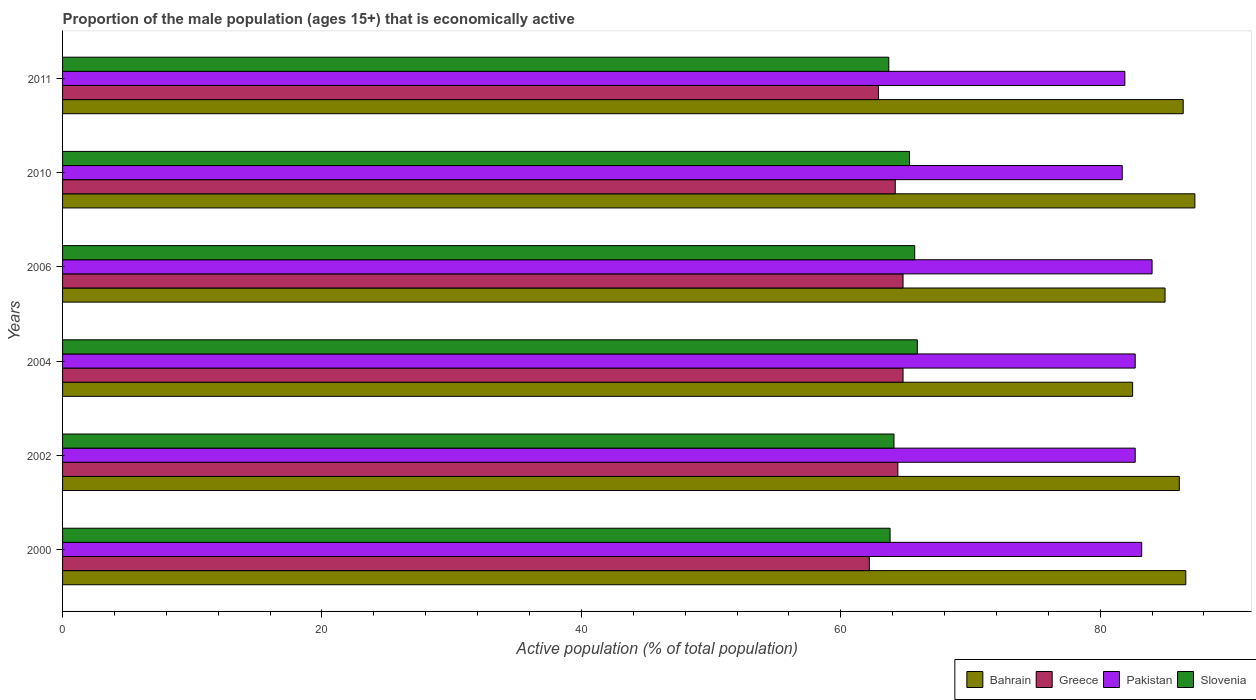How many different coloured bars are there?
Provide a succinct answer. 4. Are the number of bars per tick equal to the number of legend labels?
Provide a succinct answer. Yes. Are the number of bars on each tick of the Y-axis equal?
Offer a very short reply. Yes. How many bars are there on the 3rd tick from the top?
Provide a short and direct response. 4. What is the proportion of the male population that is economically active in Slovenia in 2000?
Ensure brevity in your answer.  63.8. Across all years, what is the maximum proportion of the male population that is economically active in Bahrain?
Keep it short and to the point. 87.3. Across all years, what is the minimum proportion of the male population that is economically active in Greece?
Your answer should be very brief. 62.2. In which year was the proportion of the male population that is economically active in Pakistan maximum?
Ensure brevity in your answer.  2006. What is the total proportion of the male population that is economically active in Slovenia in the graph?
Your response must be concise. 388.5. What is the difference between the proportion of the male population that is economically active in Slovenia in 2000 and that in 2006?
Your answer should be very brief. -1.9. What is the difference between the proportion of the male population that is economically active in Slovenia in 2010 and the proportion of the male population that is economically active in Greece in 2011?
Provide a succinct answer. 2.4. What is the average proportion of the male population that is economically active in Pakistan per year?
Provide a succinct answer. 82.7. In the year 2002, what is the difference between the proportion of the male population that is economically active in Pakistan and proportion of the male population that is economically active in Bahrain?
Offer a terse response. -3.4. In how many years, is the proportion of the male population that is economically active in Greece greater than 56 %?
Give a very brief answer. 6. What is the ratio of the proportion of the male population that is economically active in Slovenia in 2000 to that in 2002?
Your response must be concise. 1. Is the difference between the proportion of the male population that is economically active in Pakistan in 2000 and 2004 greater than the difference between the proportion of the male population that is economically active in Bahrain in 2000 and 2004?
Ensure brevity in your answer.  No. What is the difference between the highest and the lowest proportion of the male population that is economically active in Bahrain?
Your answer should be compact. 4.8. Is it the case that in every year, the sum of the proportion of the male population that is economically active in Greece and proportion of the male population that is economically active in Bahrain is greater than the sum of proportion of the male population that is economically active in Slovenia and proportion of the male population that is economically active in Pakistan?
Offer a very short reply. No. What does the 1st bar from the top in 2011 represents?
Give a very brief answer. Slovenia. What is the difference between two consecutive major ticks on the X-axis?
Offer a terse response. 20. How many legend labels are there?
Offer a very short reply. 4. How are the legend labels stacked?
Offer a very short reply. Horizontal. What is the title of the graph?
Your answer should be compact. Proportion of the male population (ages 15+) that is economically active. Does "Kenya" appear as one of the legend labels in the graph?
Offer a very short reply. No. What is the label or title of the X-axis?
Offer a terse response. Active population (% of total population). What is the Active population (% of total population) of Bahrain in 2000?
Offer a very short reply. 86.6. What is the Active population (% of total population) of Greece in 2000?
Offer a very short reply. 62.2. What is the Active population (% of total population) in Pakistan in 2000?
Provide a succinct answer. 83.2. What is the Active population (% of total population) of Slovenia in 2000?
Provide a succinct answer. 63.8. What is the Active population (% of total population) of Bahrain in 2002?
Make the answer very short. 86.1. What is the Active population (% of total population) of Greece in 2002?
Give a very brief answer. 64.4. What is the Active population (% of total population) of Pakistan in 2002?
Offer a terse response. 82.7. What is the Active population (% of total population) in Slovenia in 2002?
Your answer should be compact. 64.1. What is the Active population (% of total population) in Bahrain in 2004?
Your answer should be very brief. 82.5. What is the Active population (% of total population) in Greece in 2004?
Keep it short and to the point. 64.8. What is the Active population (% of total population) in Pakistan in 2004?
Keep it short and to the point. 82.7. What is the Active population (% of total population) of Slovenia in 2004?
Make the answer very short. 65.9. What is the Active population (% of total population) of Bahrain in 2006?
Your response must be concise. 85. What is the Active population (% of total population) of Greece in 2006?
Give a very brief answer. 64.8. What is the Active population (% of total population) in Slovenia in 2006?
Your response must be concise. 65.7. What is the Active population (% of total population) in Bahrain in 2010?
Your response must be concise. 87.3. What is the Active population (% of total population) of Greece in 2010?
Keep it short and to the point. 64.2. What is the Active population (% of total population) in Pakistan in 2010?
Your answer should be compact. 81.7. What is the Active population (% of total population) in Slovenia in 2010?
Offer a terse response. 65.3. What is the Active population (% of total population) of Bahrain in 2011?
Ensure brevity in your answer.  86.4. What is the Active population (% of total population) of Greece in 2011?
Offer a terse response. 62.9. What is the Active population (% of total population) of Pakistan in 2011?
Your answer should be compact. 81.9. What is the Active population (% of total population) of Slovenia in 2011?
Your response must be concise. 63.7. Across all years, what is the maximum Active population (% of total population) of Bahrain?
Your response must be concise. 87.3. Across all years, what is the maximum Active population (% of total population) in Greece?
Provide a short and direct response. 64.8. Across all years, what is the maximum Active population (% of total population) in Slovenia?
Make the answer very short. 65.9. Across all years, what is the minimum Active population (% of total population) in Bahrain?
Offer a terse response. 82.5. Across all years, what is the minimum Active population (% of total population) of Greece?
Make the answer very short. 62.2. Across all years, what is the minimum Active population (% of total population) of Pakistan?
Make the answer very short. 81.7. Across all years, what is the minimum Active population (% of total population) of Slovenia?
Offer a terse response. 63.7. What is the total Active population (% of total population) of Bahrain in the graph?
Ensure brevity in your answer.  513.9. What is the total Active population (% of total population) of Greece in the graph?
Ensure brevity in your answer.  383.3. What is the total Active population (% of total population) in Pakistan in the graph?
Your answer should be compact. 496.2. What is the total Active population (% of total population) in Slovenia in the graph?
Provide a succinct answer. 388.5. What is the difference between the Active population (% of total population) of Pakistan in 2000 and that in 2004?
Provide a short and direct response. 0.5. What is the difference between the Active population (% of total population) of Slovenia in 2000 and that in 2004?
Your answer should be compact. -2.1. What is the difference between the Active population (% of total population) of Greece in 2000 and that in 2006?
Give a very brief answer. -2.6. What is the difference between the Active population (% of total population) in Pakistan in 2000 and that in 2006?
Keep it short and to the point. -0.8. What is the difference between the Active population (% of total population) in Slovenia in 2000 and that in 2006?
Your response must be concise. -1.9. What is the difference between the Active population (% of total population) of Greece in 2000 and that in 2010?
Make the answer very short. -2. What is the difference between the Active population (% of total population) in Slovenia in 2000 and that in 2010?
Ensure brevity in your answer.  -1.5. What is the difference between the Active population (% of total population) in Bahrain in 2000 and that in 2011?
Keep it short and to the point. 0.2. What is the difference between the Active population (% of total population) of Greece in 2000 and that in 2011?
Your answer should be very brief. -0.7. What is the difference between the Active population (% of total population) in Slovenia in 2000 and that in 2011?
Give a very brief answer. 0.1. What is the difference between the Active population (% of total population) of Bahrain in 2002 and that in 2004?
Provide a short and direct response. 3.6. What is the difference between the Active population (% of total population) of Slovenia in 2002 and that in 2004?
Your answer should be very brief. -1.8. What is the difference between the Active population (% of total population) of Bahrain in 2002 and that in 2006?
Ensure brevity in your answer.  1.1. What is the difference between the Active population (% of total population) in Greece in 2002 and that in 2006?
Keep it short and to the point. -0.4. What is the difference between the Active population (% of total population) of Pakistan in 2002 and that in 2006?
Keep it short and to the point. -1.3. What is the difference between the Active population (% of total population) in Slovenia in 2002 and that in 2006?
Ensure brevity in your answer.  -1.6. What is the difference between the Active population (% of total population) in Bahrain in 2002 and that in 2010?
Your response must be concise. -1.2. What is the difference between the Active population (% of total population) in Slovenia in 2002 and that in 2011?
Offer a terse response. 0.4. What is the difference between the Active population (% of total population) in Bahrain in 2004 and that in 2006?
Keep it short and to the point. -2.5. What is the difference between the Active population (% of total population) in Greece in 2004 and that in 2010?
Offer a terse response. 0.6. What is the difference between the Active population (% of total population) of Pakistan in 2004 and that in 2010?
Make the answer very short. 1. What is the difference between the Active population (% of total population) of Slovenia in 2004 and that in 2010?
Provide a short and direct response. 0.6. What is the difference between the Active population (% of total population) of Pakistan in 2004 and that in 2011?
Offer a very short reply. 0.8. What is the difference between the Active population (% of total population) of Bahrain in 2006 and that in 2010?
Ensure brevity in your answer.  -2.3. What is the difference between the Active population (% of total population) in Slovenia in 2006 and that in 2010?
Provide a succinct answer. 0.4. What is the difference between the Active population (% of total population) in Greece in 2006 and that in 2011?
Offer a very short reply. 1.9. What is the difference between the Active population (% of total population) of Bahrain in 2010 and that in 2011?
Provide a short and direct response. 0.9. What is the difference between the Active population (% of total population) in Slovenia in 2010 and that in 2011?
Offer a terse response. 1.6. What is the difference between the Active population (% of total population) in Bahrain in 2000 and the Active population (% of total population) in Greece in 2002?
Provide a short and direct response. 22.2. What is the difference between the Active population (% of total population) of Bahrain in 2000 and the Active population (% of total population) of Pakistan in 2002?
Your response must be concise. 3.9. What is the difference between the Active population (% of total population) of Greece in 2000 and the Active population (% of total population) of Pakistan in 2002?
Make the answer very short. -20.5. What is the difference between the Active population (% of total population) in Greece in 2000 and the Active population (% of total population) in Slovenia in 2002?
Provide a short and direct response. -1.9. What is the difference between the Active population (% of total population) of Bahrain in 2000 and the Active population (% of total population) of Greece in 2004?
Your response must be concise. 21.8. What is the difference between the Active population (% of total population) of Bahrain in 2000 and the Active population (% of total population) of Slovenia in 2004?
Your answer should be very brief. 20.7. What is the difference between the Active population (% of total population) of Greece in 2000 and the Active population (% of total population) of Pakistan in 2004?
Offer a terse response. -20.5. What is the difference between the Active population (% of total population) in Greece in 2000 and the Active population (% of total population) in Slovenia in 2004?
Your response must be concise. -3.7. What is the difference between the Active population (% of total population) in Pakistan in 2000 and the Active population (% of total population) in Slovenia in 2004?
Your answer should be very brief. 17.3. What is the difference between the Active population (% of total population) in Bahrain in 2000 and the Active population (% of total population) in Greece in 2006?
Keep it short and to the point. 21.8. What is the difference between the Active population (% of total population) of Bahrain in 2000 and the Active population (% of total population) of Pakistan in 2006?
Offer a very short reply. 2.6. What is the difference between the Active population (% of total population) in Bahrain in 2000 and the Active population (% of total population) in Slovenia in 2006?
Provide a succinct answer. 20.9. What is the difference between the Active population (% of total population) in Greece in 2000 and the Active population (% of total population) in Pakistan in 2006?
Provide a succinct answer. -21.8. What is the difference between the Active population (% of total population) of Greece in 2000 and the Active population (% of total population) of Slovenia in 2006?
Your answer should be very brief. -3.5. What is the difference between the Active population (% of total population) in Bahrain in 2000 and the Active population (% of total population) in Greece in 2010?
Ensure brevity in your answer.  22.4. What is the difference between the Active population (% of total population) of Bahrain in 2000 and the Active population (% of total population) of Pakistan in 2010?
Offer a terse response. 4.9. What is the difference between the Active population (% of total population) of Bahrain in 2000 and the Active population (% of total population) of Slovenia in 2010?
Give a very brief answer. 21.3. What is the difference between the Active population (% of total population) in Greece in 2000 and the Active population (% of total population) in Pakistan in 2010?
Make the answer very short. -19.5. What is the difference between the Active population (% of total population) in Greece in 2000 and the Active population (% of total population) in Slovenia in 2010?
Make the answer very short. -3.1. What is the difference between the Active population (% of total population) in Pakistan in 2000 and the Active population (% of total population) in Slovenia in 2010?
Give a very brief answer. 17.9. What is the difference between the Active population (% of total population) of Bahrain in 2000 and the Active population (% of total population) of Greece in 2011?
Your answer should be compact. 23.7. What is the difference between the Active population (% of total population) in Bahrain in 2000 and the Active population (% of total population) in Pakistan in 2011?
Your answer should be very brief. 4.7. What is the difference between the Active population (% of total population) in Bahrain in 2000 and the Active population (% of total population) in Slovenia in 2011?
Offer a terse response. 22.9. What is the difference between the Active population (% of total population) in Greece in 2000 and the Active population (% of total population) in Pakistan in 2011?
Offer a terse response. -19.7. What is the difference between the Active population (% of total population) in Pakistan in 2000 and the Active population (% of total population) in Slovenia in 2011?
Your answer should be compact. 19.5. What is the difference between the Active population (% of total population) of Bahrain in 2002 and the Active population (% of total population) of Greece in 2004?
Your answer should be compact. 21.3. What is the difference between the Active population (% of total population) in Bahrain in 2002 and the Active population (% of total population) in Slovenia in 2004?
Give a very brief answer. 20.2. What is the difference between the Active population (% of total population) in Greece in 2002 and the Active population (% of total population) in Pakistan in 2004?
Your answer should be compact. -18.3. What is the difference between the Active population (% of total population) in Bahrain in 2002 and the Active population (% of total population) in Greece in 2006?
Your answer should be compact. 21.3. What is the difference between the Active population (% of total population) in Bahrain in 2002 and the Active population (% of total population) in Pakistan in 2006?
Offer a very short reply. 2.1. What is the difference between the Active population (% of total population) in Bahrain in 2002 and the Active population (% of total population) in Slovenia in 2006?
Your response must be concise. 20.4. What is the difference between the Active population (% of total population) in Greece in 2002 and the Active population (% of total population) in Pakistan in 2006?
Ensure brevity in your answer.  -19.6. What is the difference between the Active population (% of total population) of Bahrain in 2002 and the Active population (% of total population) of Greece in 2010?
Offer a very short reply. 21.9. What is the difference between the Active population (% of total population) in Bahrain in 2002 and the Active population (% of total population) in Slovenia in 2010?
Offer a very short reply. 20.8. What is the difference between the Active population (% of total population) in Greece in 2002 and the Active population (% of total population) in Pakistan in 2010?
Give a very brief answer. -17.3. What is the difference between the Active population (% of total population) in Bahrain in 2002 and the Active population (% of total population) in Greece in 2011?
Your response must be concise. 23.2. What is the difference between the Active population (% of total population) of Bahrain in 2002 and the Active population (% of total population) of Pakistan in 2011?
Keep it short and to the point. 4.2. What is the difference between the Active population (% of total population) in Bahrain in 2002 and the Active population (% of total population) in Slovenia in 2011?
Your response must be concise. 22.4. What is the difference between the Active population (% of total population) of Greece in 2002 and the Active population (% of total population) of Pakistan in 2011?
Provide a succinct answer. -17.5. What is the difference between the Active population (% of total population) in Greece in 2002 and the Active population (% of total population) in Slovenia in 2011?
Make the answer very short. 0.7. What is the difference between the Active population (% of total population) of Pakistan in 2002 and the Active population (% of total population) of Slovenia in 2011?
Provide a short and direct response. 19. What is the difference between the Active population (% of total population) of Greece in 2004 and the Active population (% of total population) of Pakistan in 2006?
Provide a succinct answer. -19.2. What is the difference between the Active population (% of total population) in Greece in 2004 and the Active population (% of total population) in Slovenia in 2006?
Your answer should be compact. -0.9. What is the difference between the Active population (% of total population) in Greece in 2004 and the Active population (% of total population) in Pakistan in 2010?
Keep it short and to the point. -16.9. What is the difference between the Active population (% of total population) of Pakistan in 2004 and the Active population (% of total population) of Slovenia in 2010?
Provide a short and direct response. 17.4. What is the difference between the Active population (% of total population) of Bahrain in 2004 and the Active population (% of total population) of Greece in 2011?
Your answer should be compact. 19.6. What is the difference between the Active population (% of total population) of Greece in 2004 and the Active population (% of total population) of Pakistan in 2011?
Keep it short and to the point. -17.1. What is the difference between the Active population (% of total population) in Pakistan in 2004 and the Active population (% of total population) in Slovenia in 2011?
Provide a succinct answer. 19. What is the difference between the Active population (% of total population) of Bahrain in 2006 and the Active population (% of total population) of Greece in 2010?
Your answer should be very brief. 20.8. What is the difference between the Active population (% of total population) of Bahrain in 2006 and the Active population (% of total population) of Pakistan in 2010?
Your answer should be compact. 3.3. What is the difference between the Active population (% of total population) of Greece in 2006 and the Active population (% of total population) of Pakistan in 2010?
Your answer should be compact. -16.9. What is the difference between the Active population (% of total population) of Bahrain in 2006 and the Active population (% of total population) of Greece in 2011?
Your answer should be very brief. 22.1. What is the difference between the Active population (% of total population) in Bahrain in 2006 and the Active population (% of total population) in Slovenia in 2011?
Ensure brevity in your answer.  21.3. What is the difference between the Active population (% of total population) of Greece in 2006 and the Active population (% of total population) of Pakistan in 2011?
Give a very brief answer. -17.1. What is the difference between the Active population (% of total population) in Pakistan in 2006 and the Active population (% of total population) in Slovenia in 2011?
Offer a very short reply. 20.3. What is the difference between the Active population (% of total population) of Bahrain in 2010 and the Active population (% of total population) of Greece in 2011?
Ensure brevity in your answer.  24.4. What is the difference between the Active population (% of total population) of Bahrain in 2010 and the Active population (% of total population) of Pakistan in 2011?
Offer a very short reply. 5.4. What is the difference between the Active population (% of total population) of Bahrain in 2010 and the Active population (% of total population) of Slovenia in 2011?
Offer a very short reply. 23.6. What is the difference between the Active population (% of total population) of Greece in 2010 and the Active population (% of total population) of Pakistan in 2011?
Your answer should be compact. -17.7. What is the difference between the Active population (% of total population) in Pakistan in 2010 and the Active population (% of total population) in Slovenia in 2011?
Make the answer very short. 18. What is the average Active population (% of total population) of Bahrain per year?
Offer a very short reply. 85.65. What is the average Active population (% of total population) of Greece per year?
Make the answer very short. 63.88. What is the average Active population (% of total population) of Pakistan per year?
Provide a succinct answer. 82.7. What is the average Active population (% of total population) of Slovenia per year?
Provide a succinct answer. 64.75. In the year 2000, what is the difference between the Active population (% of total population) of Bahrain and Active population (% of total population) of Greece?
Ensure brevity in your answer.  24.4. In the year 2000, what is the difference between the Active population (% of total population) in Bahrain and Active population (% of total population) in Slovenia?
Make the answer very short. 22.8. In the year 2000, what is the difference between the Active population (% of total population) of Greece and Active population (% of total population) of Pakistan?
Make the answer very short. -21. In the year 2002, what is the difference between the Active population (% of total population) of Bahrain and Active population (% of total population) of Greece?
Your answer should be compact. 21.7. In the year 2002, what is the difference between the Active population (% of total population) of Bahrain and Active population (% of total population) of Pakistan?
Give a very brief answer. 3.4. In the year 2002, what is the difference between the Active population (% of total population) of Greece and Active population (% of total population) of Pakistan?
Provide a short and direct response. -18.3. In the year 2002, what is the difference between the Active population (% of total population) of Greece and Active population (% of total population) of Slovenia?
Your answer should be compact. 0.3. In the year 2002, what is the difference between the Active population (% of total population) in Pakistan and Active population (% of total population) in Slovenia?
Your answer should be compact. 18.6. In the year 2004, what is the difference between the Active population (% of total population) of Bahrain and Active population (% of total population) of Greece?
Your answer should be compact. 17.7. In the year 2004, what is the difference between the Active population (% of total population) of Bahrain and Active population (% of total population) of Slovenia?
Your response must be concise. 16.6. In the year 2004, what is the difference between the Active population (% of total population) of Greece and Active population (% of total population) of Pakistan?
Your answer should be very brief. -17.9. In the year 2004, what is the difference between the Active population (% of total population) of Pakistan and Active population (% of total population) of Slovenia?
Your response must be concise. 16.8. In the year 2006, what is the difference between the Active population (% of total population) of Bahrain and Active population (% of total population) of Greece?
Keep it short and to the point. 20.2. In the year 2006, what is the difference between the Active population (% of total population) of Bahrain and Active population (% of total population) of Slovenia?
Provide a short and direct response. 19.3. In the year 2006, what is the difference between the Active population (% of total population) of Greece and Active population (% of total population) of Pakistan?
Your answer should be compact. -19.2. In the year 2010, what is the difference between the Active population (% of total population) in Bahrain and Active population (% of total population) in Greece?
Make the answer very short. 23.1. In the year 2010, what is the difference between the Active population (% of total population) in Bahrain and Active population (% of total population) in Slovenia?
Provide a succinct answer. 22. In the year 2010, what is the difference between the Active population (% of total population) of Greece and Active population (% of total population) of Pakistan?
Your response must be concise. -17.5. In the year 2010, what is the difference between the Active population (% of total population) in Greece and Active population (% of total population) in Slovenia?
Provide a short and direct response. -1.1. In the year 2010, what is the difference between the Active population (% of total population) in Pakistan and Active population (% of total population) in Slovenia?
Your answer should be compact. 16.4. In the year 2011, what is the difference between the Active population (% of total population) in Bahrain and Active population (% of total population) in Slovenia?
Ensure brevity in your answer.  22.7. What is the ratio of the Active population (% of total population) in Greece in 2000 to that in 2002?
Make the answer very short. 0.97. What is the ratio of the Active population (% of total population) of Pakistan in 2000 to that in 2002?
Provide a short and direct response. 1.01. What is the ratio of the Active population (% of total population) in Bahrain in 2000 to that in 2004?
Give a very brief answer. 1.05. What is the ratio of the Active population (% of total population) in Greece in 2000 to that in 2004?
Offer a terse response. 0.96. What is the ratio of the Active population (% of total population) of Pakistan in 2000 to that in 2004?
Your answer should be very brief. 1.01. What is the ratio of the Active population (% of total population) in Slovenia in 2000 to that in 2004?
Your answer should be compact. 0.97. What is the ratio of the Active population (% of total population) of Bahrain in 2000 to that in 2006?
Your answer should be compact. 1.02. What is the ratio of the Active population (% of total population) in Greece in 2000 to that in 2006?
Provide a short and direct response. 0.96. What is the ratio of the Active population (% of total population) of Pakistan in 2000 to that in 2006?
Give a very brief answer. 0.99. What is the ratio of the Active population (% of total population) in Slovenia in 2000 to that in 2006?
Provide a succinct answer. 0.97. What is the ratio of the Active population (% of total population) of Greece in 2000 to that in 2010?
Your answer should be very brief. 0.97. What is the ratio of the Active population (% of total population) of Pakistan in 2000 to that in 2010?
Your response must be concise. 1.02. What is the ratio of the Active population (% of total population) of Greece in 2000 to that in 2011?
Offer a very short reply. 0.99. What is the ratio of the Active population (% of total population) in Pakistan in 2000 to that in 2011?
Provide a succinct answer. 1.02. What is the ratio of the Active population (% of total population) of Slovenia in 2000 to that in 2011?
Your response must be concise. 1. What is the ratio of the Active population (% of total population) of Bahrain in 2002 to that in 2004?
Ensure brevity in your answer.  1.04. What is the ratio of the Active population (% of total population) of Slovenia in 2002 to that in 2004?
Keep it short and to the point. 0.97. What is the ratio of the Active population (% of total population) of Bahrain in 2002 to that in 2006?
Keep it short and to the point. 1.01. What is the ratio of the Active population (% of total population) of Pakistan in 2002 to that in 2006?
Offer a terse response. 0.98. What is the ratio of the Active population (% of total population) of Slovenia in 2002 to that in 2006?
Keep it short and to the point. 0.98. What is the ratio of the Active population (% of total population) of Bahrain in 2002 to that in 2010?
Keep it short and to the point. 0.99. What is the ratio of the Active population (% of total population) in Pakistan in 2002 to that in 2010?
Provide a succinct answer. 1.01. What is the ratio of the Active population (% of total population) in Slovenia in 2002 to that in 2010?
Offer a terse response. 0.98. What is the ratio of the Active population (% of total population) in Greece in 2002 to that in 2011?
Offer a very short reply. 1.02. What is the ratio of the Active population (% of total population) of Pakistan in 2002 to that in 2011?
Your answer should be very brief. 1.01. What is the ratio of the Active population (% of total population) of Bahrain in 2004 to that in 2006?
Provide a succinct answer. 0.97. What is the ratio of the Active population (% of total population) of Pakistan in 2004 to that in 2006?
Give a very brief answer. 0.98. What is the ratio of the Active population (% of total population) of Slovenia in 2004 to that in 2006?
Provide a short and direct response. 1. What is the ratio of the Active population (% of total population) in Bahrain in 2004 to that in 2010?
Make the answer very short. 0.94. What is the ratio of the Active population (% of total population) in Greece in 2004 to that in 2010?
Give a very brief answer. 1.01. What is the ratio of the Active population (% of total population) in Pakistan in 2004 to that in 2010?
Your answer should be compact. 1.01. What is the ratio of the Active population (% of total population) of Slovenia in 2004 to that in 2010?
Ensure brevity in your answer.  1.01. What is the ratio of the Active population (% of total population) in Bahrain in 2004 to that in 2011?
Offer a very short reply. 0.95. What is the ratio of the Active population (% of total population) of Greece in 2004 to that in 2011?
Provide a succinct answer. 1.03. What is the ratio of the Active population (% of total population) of Pakistan in 2004 to that in 2011?
Provide a succinct answer. 1.01. What is the ratio of the Active population (% of total population) of Slovenia in 2004 to that in 2011?
Your response must be concise. 1.03. What is the ratio of the Active population (% of total population) in Bahrain in 2006 to that in 2010?
Offer a very short reply. 0.97. What is the ratio of the Active population (% of total population) in Greece in 2006 to that in 2010?
Offer a terse response. 1.01. What is the ratio of the Active population (% of total population) of Pakistan in 2006 to that in 2010?
Provide a short and direct response. 1.03. What is the ratio of the Active population (% of total population) in Slovenia in 2006 to that in 2010?
Provide a succinct answer. 1.01. What is the ratio of the Active population (% of total population) in Bahrain in 2006 to that in 2011?
Provide a short and direct response. 0.98. What is the ratio of the Active population (% of total population) of Greece in 2006 to that in 2011?
Offer a very short reply. 1.03. What is the ratio of the Active population (% of total population) in Pakistan in 2006 to that in 2011?
Your answer should be compact. 1.03. What is the ratio of the Active population (% of total population) of Slovenia in 2006 to that in 2011?
Offer a terse response. 1.03. What is the ratio of the Active population (% of total population) in Bahrain in 2010 to that in 2011?
Offer a very short reply. 1.01. What is the ratio of the Active population (% of total population) in Greece in 2010 to that in 2011?
Ensure brevity in your answer.  1.02. What is the ratio of the Active population (% of total population) of Slovenia in 2010 to that in 2011?
Give a very brief answer. 1.03. What is the difference between the highest and the second highest Active population (% of total population) in Bahrain?
Make the answer very short. 0.7. What is the difference between the highest and the second highest Active population (% of total population) of Greece?
Give a very brief answer. 0. What is the difference between the highest and the second highest Active population (% of total population) in Pakistan?
Your answer should be compact. 0.8. What is the difference between the highest and the second highest Active population (% of total population) in Slovenia?
Provide a succinct answer. 0.2. What is the difference between the highest and the lowest Active population (% of total population) of Bahrain?
Your answer should be very brief. 4.8. What is the difference between the highest and the lowest Active population (% of total population) in Pakistan?
Provide a short and direct response. 2.3. 